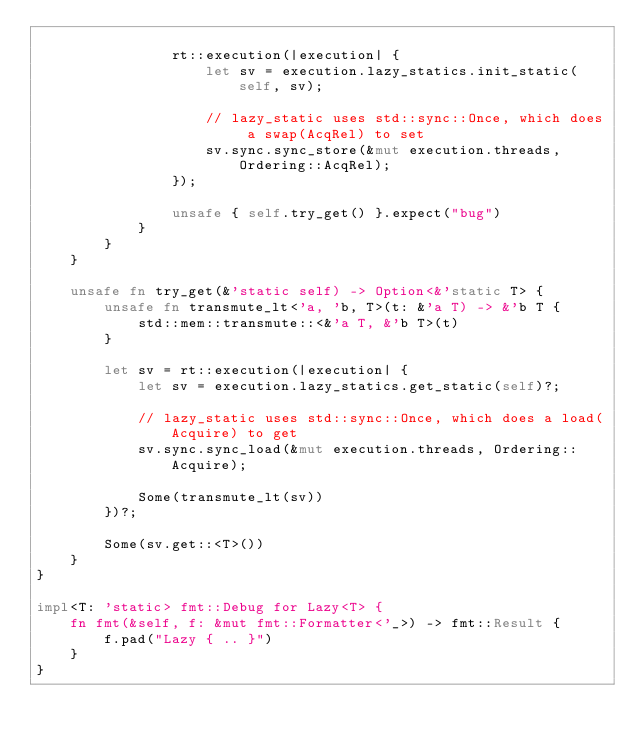Convert code to text. <code><loc_0><loc_0><loc_500><loc_500><_Rust_>
                rt::execution(|execution| {
                    let sv = execution.lazy_statics.init_static(self, sv);

                    // lazy_static uses std::sync::Once, which does a swap(AcqRel) to set
                    sv.sync.sync_store(&mut execution.threads, Ordering::AcqRel);
                });

                unsafe { self.try_get() }.expect("bug")
            }
        }
    }

    unsafe fn try_get(&'static self) -> Option<&'static T> {
        unsafe fn transmute_lt<'a, 'b, T>(t: &'a T) -> &'b T {
            std::mem::transmute::<&'a T, &'b T>(t)
        }

        let sv = rt::execution(|execution| {
            let sv = execution.lazy_statics.get_static(self)?;

            // lazy_static uses std::sync::Once, which does a load(Acquire) to get
            sv.sync.sync_load(&mut execution.threads, Ordering::Acquire);

            Some(transmute_lt(sv))
        })?;

        Some(sv.get::<T>())
    }
}

impl<T: 'static> fmt::Debug for Lazy<T> {
    fn fmt(&self, f: &mut fmt::Formatter<'_>) -> fmt::Result {
        f.pad("Lazy { .. }")
    }
}
</code> 